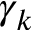Convert formula to latex. <formula><loc_0><loc_0><loc_500><loc_500>\gamma _ { k }</formula> 